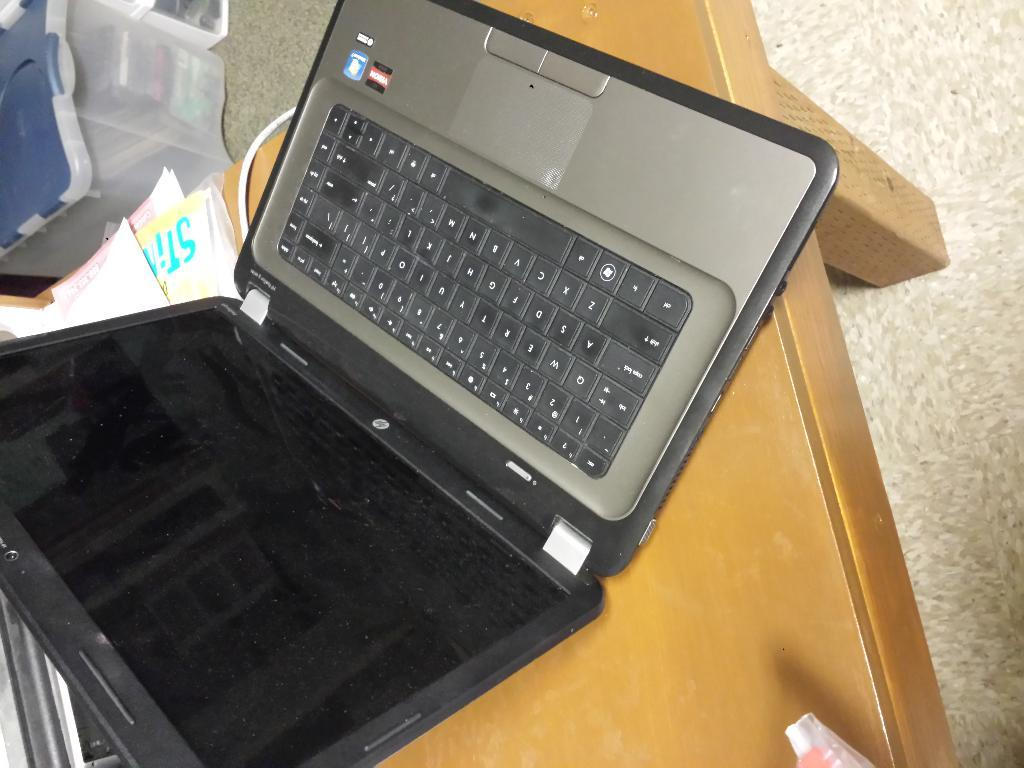<image>
Summarize the visual content of the image. An open laptop which is upside down and has a caps lock key visible. 